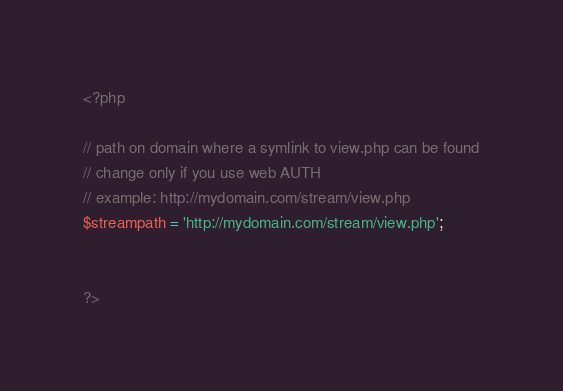<code> <loc_0><loc_0><loc_500><loc_500><_PHP_><?php

// path on domain where a symlink to view.php can be found
// change only if you use web AUTH
// example: http://mydomain.com/stream/view.php
$streampath = 'http://mydomain.com/stream/view.php'; 


?></code> 